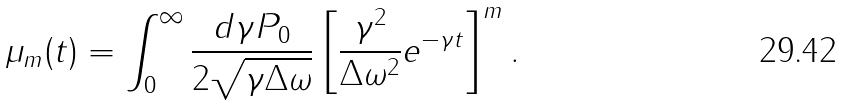Convert formula to latex. <formula><loc_0><loc_0><loc_500><loc_500>\mu _ { m } ( t ) = \int _ { 0 } ^ { \infty } \frac { d \gamma P _ { 0 } } { 2 \sqrt { \gamma \Delta \omega } } \left [ \frac { \gamma ^ { 2 } } { \Delta \omega ^ { 2 } } e ^ { - \gamma t } \right ] ^ { m } .</formula> 